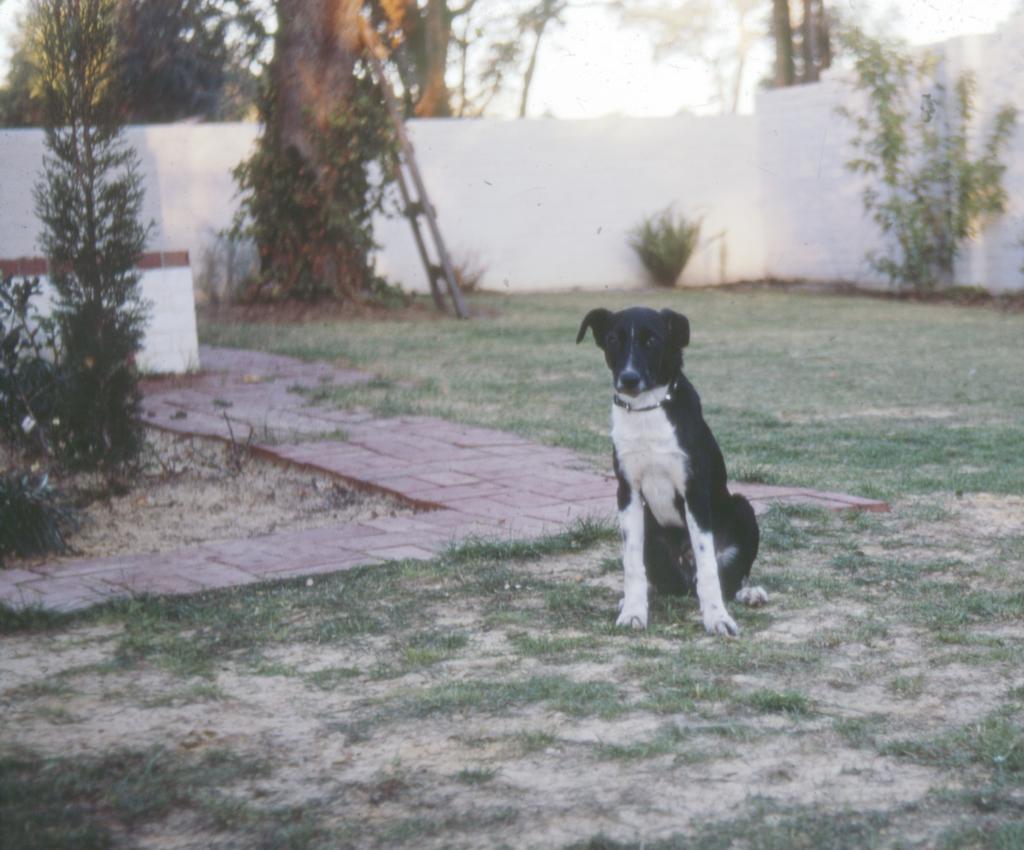Describe this image in one or two sentences. In this image I can see a dog in white and black color. Back I can see few trees, ladder, white wall and sky is in white color. 